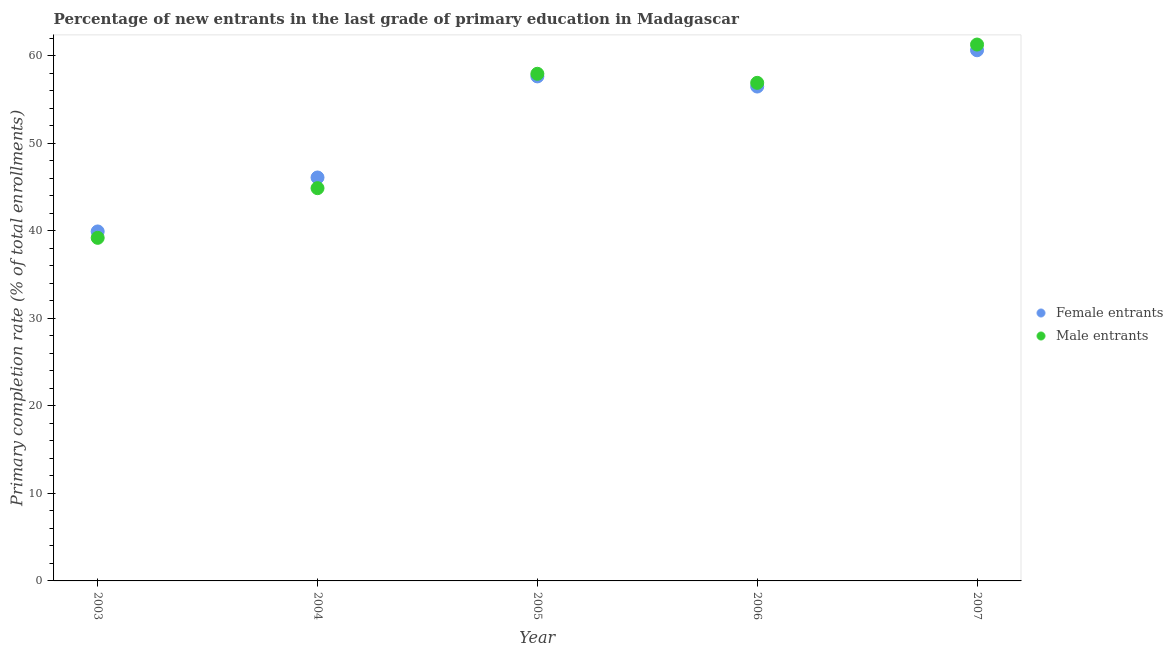How many different coloured dotlines are there?
Offer a very short reply. 2. Is the number of dotlines equal to the number of legend labels?
Provide a succinct answer. Yes. What is the primary completion rate of female entrants in 2003?
Ensure brevity in your answer.  39.91. Across all years, what is the maximum primary completion rate of female entrants?
Provide a succinct answer. 60.61. Across all years, what is the minimum primary completion rate of male entrants?
Your answer should be compact. 39.18. In which year was the primary completion rate of male entrants maximum?
Give a very brief answer. 2007. In which year was the primary completion rate of male entrants minimum?
Your answer should be very brief. 2003. What is the total primary completion rate of female entrants in the graph?
Provide a succinct answer. 260.69. What is the difference between the primary completion rate of female entrants in 2004 and that in 2007?
Make the answer very short. -14.53. What is the difference between the primary completion rate of female entrants in 2007 and the primary completion rate of male entrants in 2006?
Provide a short and direct response. 3.72. What is the average primary completion rate of male entrants per year?
Offer a very short reply. 52.02. In the year 2003, what is the difference between the primary completion rate of female entrants and primary completion rate of male entrants?
Offer a terse response. 0.73. What is the ratio of the primary completion rate of female entrants in 2004 to that in 2007?
Your answer should be very brief. 0.76. Is the difference between the primary completion rate of female entrants in 2004 and 2006 greater than the difference between the primary completion rate of male entrants in 2004 and 2006?
Make the answer very short. Yes. What is the difference between the highest and the second highest primary completion rate of female entrants?
Keep it short and to the point. 2.99. What is the difference between the highest and the lowest primary completion rate of male entrants?
Ensure brevity in your answer.  22.08. Is the sum of the primary completion rate of female entrants in 2003 and 2004 greater than the maximum primary completion rate of male entrants across all years?
Provide a short and direct response. Yes. Does the primary completion rate of female entrants monotonically increase over the years?
Keep it short and to the point. No. How many dotlines are there?
Ensure brevity in your answer.  2. Does the graph contain grids?
Ensure brevity in your answer.  No. What is the title of the graph?
Give a very brief answer. Percentage of new entrants in the last grade of primary education in Madagascar. Does "RDB nonconcessional" appear as one of the legend labels in the graph?
Keep it short and to the point. No. What is the label or title of the X-axis?
Offer a very short reply. Year. What is the label or title of the Y-axis?
Your answer should be very brief. Primary completion rate (% of total enrollments). What is the Primary completion rate (% of total enrollments) of Female entrants in 2003?
Your answer should be very brief. 39.91. What is the Primary completion rate (% of total enrollments) in Male entrants in 2003?
Give a very brief answer. 39.18. What is the Primary completion rate (% of total enrollments) in Female entrants in 2004?
Keep it short and to the point. 46.08. What is the Primary completion rate (% of total enrollments) in Male entrants in 2004?
Keep it short and to the point. 44.86. What is the Primary completion rate (% of total enrollments) of Female entrants in 2005?
Ensure brevity in your answer.  57.62. What is the Primary completion rate (% of total enrollments) in Male entrants in 2005?
Provide a short and direct response. 57.92. What is the Primary completion rate (% of total enrollments) of Female entrants in 2006?
Your response must be concise. 56.47. What is the Primary completion rate (% of total enrollments) in Male entrants in 2006?
Provide a succinct answer. 56.89. What is the Primary completion rate (% of total enrollments) in Female entrants in 2007?
Offer a terse response. 60.61. What is the Primary completion rate (% of total enrollments) of Male entrants in 2007?
Keep it short and to the point. 61.26. Across all years, what is the maximum Primary completion rate (% of total enrollments) in Female entrants?
Ensure brevity in your answer.  60.61. Across all years, what is the maximum Primary completion rate (% of total enrollments) in Male entrants?
Your answer should be very brief. 61.26. Across all years, what is the minimum Primary completion rate (% of total enrollments) of Female entrants?
Your answer should be very brief. 39.91. Across all years, what is the minimum Primary completion rate (% of total enrollments) of Male entrants?
Offer a terse response. 39.18. What is the total Primary completion rate (% of total enrollments) of Female entrants in the graph?
Your answer should be very brief. 260.69. What is the total Primary completion rate (% of total enrollments) in Male entrants in the graph?
Your answer should be very brief. 260.12. What is the difference between the Primary completion rate (% of total enrollments) of Female entrants in 2003 and that in 2004?
Provide a succinct answer. -6.16. What is the difference between the Primary completion rate (% of total enrollments) of Male entrants in 2003 and that in 2004?
Your answer should be very brief. -5.67. What is the difference between the Primary completion rate (% of total enrollments) of Female entrants in 2003 and that in 2005?
Your answer should be compact. -17.71. What is the difference between the Primary completion rate (% of total enrollments) in Male entrants in 2003 and that in 2005?
Ensure brevity in your answer.  -18.74. What is the difference between the Primary completion rate (% of total enrollments) in Female entrants in 2003 and that in 2006?
Offer a terse response. -16.55. What is the difference between the Primary completion rate (% of total enrollments) in Male entrants in 2003 and that in 2006?
Your answer should be compact. -17.7. What is the difference between the Primary completion rate (% of total enrollments) in Female entrants in 2003 and that in 2007?
Provide a succinct answer. -20.7. What is the difference between the Primary completion rate (% of total enrollments) in Male entrants in 2003 and that in 2007?
Provide a succinct answer. -22.08. What is the difference between the Primary completion rate (% of total enrollments) of Female entrants in 2004 and that in 2005?
Your answer should be very brief. -11.54. What is the difference between the Primary completion rate (% of total enrollments) of Male entrants in 2004 and that in 2005?
Your response must be concise. -13.06. What is the difference between the Primary completion rate (% of total enrollments) of Female entrants in 2004 and that in 2006?
Provide a succinct answer. -10.39. What is the difference between the Primary completion rate (% of total enrollments) of Male entrants in 2004 and that in 2006?
Offer a terse response. -12.03. What is the difference between the Primary completion rate (% of total enrollments) of Female entrants in 2004 and that in 2007?
Give a very brief answer. -14.53. What is the difference between the Primary completion rate (% of total enrollments) in Male entrants in 2004 and that in 2007?
Your answer should be compact. -16.4. What is the difference between the Primary completion rate (% of total enrollments) in Female entrants in 2005 and that in 2006?
Keep it short and to the point. 1.16. What is the difference between the Primary completion rate (% of total enrollments) in Male entrants in 2005 and that in 2006?
Offer a very short reply. 1.03. What is the difference between the Primary completion rate (% of total enrollments) in Female entrants in 2005 and that in 2007?
Provide a succinct answer. -2.99. What is the difference between the Primary completion rate (% of total enrollments) in Male entrants in 2005 and that in 2007?
Your answer should be compact. -3.34. What is the difference between the Primary completion rate (% of total enrollments) of Female entrants in 2006 and that in 2007?
Provide a succinct answer. -4.14. What is the difference between the Primary completion rate (% of total enrollments) in Male entrants in 2006 and that in 2007?
Make the answer very short. -4.37. What is the difference between the Primary completion rate (% of total enrollments) in Female entrants in 2003 and the Primary completion rate (% of total enrollments) in Male entrants in 2004?
Make the answer very short. -4.94. What is the difference between the Primary completion rate (% of total enrollments) of Female entrants in 2003 and the Primary completion rate (% of total enrollments) of Male entrants in 2005?
Keep it short and to the point. -18.01. What is the difference between the Primary completion rate (% of total enrollments) of Female entrants in 2003 and the Primary completion rate (% of total enrollments) of Male entrants in 2006?
Provide a short and direct response. -16.97. What is the difference between the Primary completion rate (% of total enrollments) in Female entrants in 2003 and the Primary completion rate (% of total enrollments) in Male entrants in 2007?
Offer a very short reply. -21.35. What is the difference between the Primary completion rate (% of total enrollments) of Female entrants in 2004 and the Primary completion rate (% of total enrollments) of Male entrants in 2005?
Make the answer very short. -11.84. What is the difference between the Primary completion rate (% of total enrollments) of Female entrants in 2004 and the Primary completion rate (% of total enrollments) of Male entrants in 2006?
Provide a succinct answer. -10.81. What is the difference between the Primary completion rate (% of total enrollments) of Female entrants in 2004 and the Primary completion rate (% of total enrollments) of Male entrants in 2007?
Keep it short and to the point. -15.18. What is the difference between the Primary completion rate (% of total enrollments) of Female entrants in 2005 and the Primary completion rate (% of total enrollments) of Male entrants in 2006?
Make the answer very short. 0.73. What is the difference between the Primary completion rate (% of total enrollments) of Female entrants in 2005 and the Primary completion rate (% of total enrollments) of Male entrants in 2007?
Your response must be concise. -3.64. What is the difference between the Primary completion rate (% of total enrollments) in Female entrants in 2006 and the Primary completion rate (% of total enrollments) in Male entrants in 2007?
Provide a succinct answer. -4.8. What is the average Primary completion rate (% of total enrollments) of Female entrants per year?
Your answer should be compact. 52.14. What is the average Primary completion rate (% of total enrollments) in Male entrants per year?
Offer a terse response. 52.02. In the year 2003, what is the difference between the Primary completion rate (% of total enrollments) of Female entrants and Primary completion rate (% of total enrollments) of Male entrants?
Your response must be concise. 0.73. In the year 2004, what is the difference between the Primary completion rate (% of total enrollments) of Female entrants and Primary completion rate (% of total enrollments) of Male entrants?
Provide a short and direct response. 1.22. In the year 2005, what is the difference between the Primary completion rate (% of total enrollments) of Female entrants and Primary completion rate (% of total enrollments) of Male entrants?
Offer a terse response. -0.3. In the year 2006, what is the difference between the Primary completion rate (% of total enrollments) of Female entrants and Primary completion rate (% of total enrollments) of Male entrants?
Your answer should be very brief. -0.42. In the year 2007, what is the difference between the Primary completion rate (% of total enrollments) in Female entrants and Primary completion rate (% of total enrollments) in Male entrants?
Offer a terse response. -0.65. What is the ratio of the Primary completion rate (% of total enrollments) in Female entrants in 2003 to that in 2004?
Keep it short and to the point. 0.87. What is the ratio of the Primary completion rate (% of total enrollments) in Male entrants in 2003 to that in 2004?
Keep it short and to the point. 0.87. What is the ratio of the Primary completion rate (% of total enrollments) in Female entrants in 2003 to that in 2005?
Provide a succinct answer. 0.69. What is the ratio of the Primary completion rate (% of total enrollments) of Male entrants in 2003 to that in 2005?
Ensure brevity in your answer.  0.68. What is the ratio of the Primary completion rate (% of total enrollments) in Female entrants in 2003 to that in 2006?
Offer a terse response. 0.71. What is the ratio of the Primary completion rate (% of total enrollments) in Male entrants in 2003 to that in 2006?
Offer a terse response. 0.69. What is the ratio of the Primary completion rate (% of total enrollments) in Female entrants in 2003 to that in 2007?
Your response must be concise. 0.66. What is the ratio of the Primary completion rate (% of total enrollments) in Male entrants in 2003 to that in 2007?
Make the answer very short. 0.64. What is the ratio of the Primary completion rate (% of total enrollments) of Female entrants in 2004 to that in 2005?
Provide a succinct answer. 0.8. What is the ratio of the Primary completion rate (% of total enrollments) of Male entrants in 2004 to that in 2005?
Make the answer very short. 0.77. What is the ratio of the Primary completion rate (% of total enrollments) of Female entrants in 2004 to that in 2006?
Ensure brevity in your answer.  0.82. What is the ratio of the Primary completion rate (% of total enrollments) in Male entrants in 2004 to that in 2006?
Provide a succinct answer. 0.79. What is the ratio of the Primary completion rate (% of total enrollments) in Female entrants in 2004 to that in 2007?
Offer a terse response. 0.76. What is the ratio of the Primary completion rate (% of total enrollments) of Male entrants in 2004 to that in 2007?
Provide a short and direct response. 0.73. What is the ratio of the Primary completion rate (% of total enrollments) in Female entrants in 2005 to that in 2006?
Offer a very short reply. 1.02. What is the ratio of the Primary completion rate (% of total enrollments) of Male entrants in 2005 to that in 2006?
Offer a very short reply. 1.02. What is the ratio of the Primary completion rate (% of total enrollments) of Female entrants in 2005 to that in 2007?
Your answer should be very brief. 0.95. What is the ratio of the Primary completion rate (% of total enrollments) in Male entrants in 2005 to that in 2007?
Offer a terse response. 0.95. What is the ratio of the Primary completion rate (% of total enrollments) in Female entrants in 2006 to that in 2007?
Make the answer very short. 0.93. What is the ratio of the Primary completion rate (% of total enrollments) of Male entrants in 2006 to that in 2007?
Provide a short and direct response. 0.93. What is the difference between the highest and the second highest Primary completion rate (% of total enrollments) of Female entrants?
Provide a succinct answer. 2.99. What is the difference between the highest and the second highest Primary completion rate (% of total enrollments) in Male entrants?
Provide a short and direct response. 3.34. What is the difference between the highest and the lowest Primary completion rate (% of total enrollments) of Female entrants?
Offer a very short reply. 20.7. What is the difference between the highest and the lowest Primary completion rate (% of total enrollments) in Male entrants?
Make the answer very short. 22.08. 